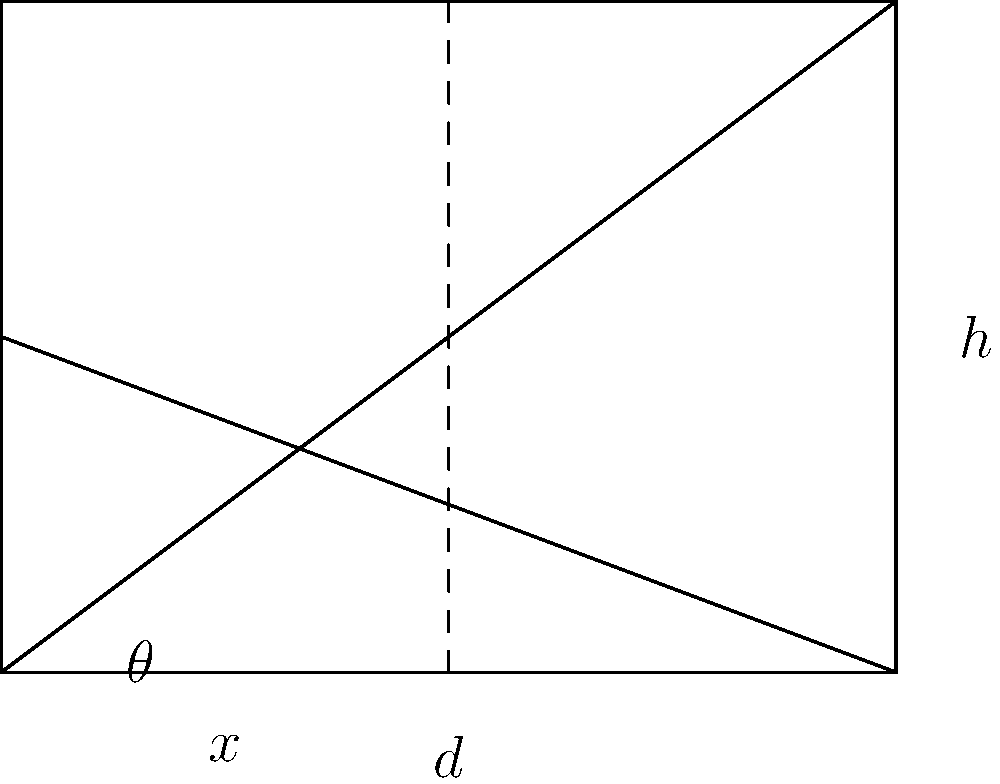In a cityscape scene, you're drawing a building with a height of 60 meters. The vanishing point is located 30 cm from the base of the building on your drawing paper. If you want to draw a horizontal line at 20 meters up the building, how far from the base of the building (in cm) should you draw this line on your paper to maintain accurate perspective? Let's approach this step-by-step:

1) First, we need to understand the relationship between the real building and our drawing. The entire height of the building (60m) corresponds to the full height of our drawn building (let's call this $h$ cm).

2) We're looking for a point that's 20m up the building, which is 1/3 of the total height (20m / 60m = 1/3).

3) In perspective drawing, we can use the principle of similar triangles. The triangle formed by the vanishing point, the base of the building, and the top of the building is similar to the triangle formed by the vanishing point, the base, and our 20m point.

4) Let $x$ be the distance we're looking for, and $d$ be the distance to the vanishing point (30 cm).

5) We can set up the following proportion based on similar triangles:

   $\frac{x}{d} = \frac{20}{60} = \frac{1}{3}$

6) Substituting the known value of $d$:

   $\frac{x}{30} = \frac{1}{3}$

7) Solving for $x$:

   $x = 30 * \frac{1}{3} = 10$

Therefore, we should draw the line 10 cm up from the base of the building on our paper.
Answer: 10 cm 